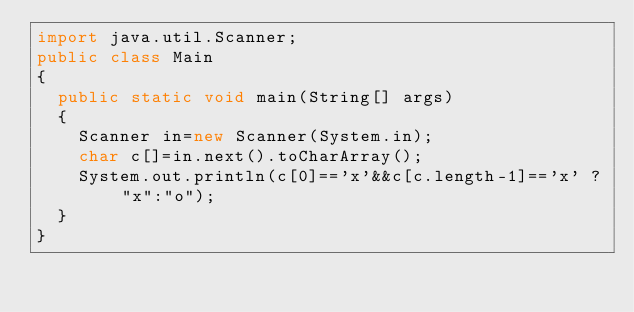Convert code to text. <code><loc_0><loc_0><loc_500><loc_500><_Java_>import java.util.Scanner;
public class Main
{
	public static void main(String[] args) 
	{
		Scanner in=new Scanner(System.in);
		char c[]=in.next().toCharArray();
		System.out.println(c[0]=='x'&&c[c.length-1]=='x' ? "x":"o");
	}
}</code> 